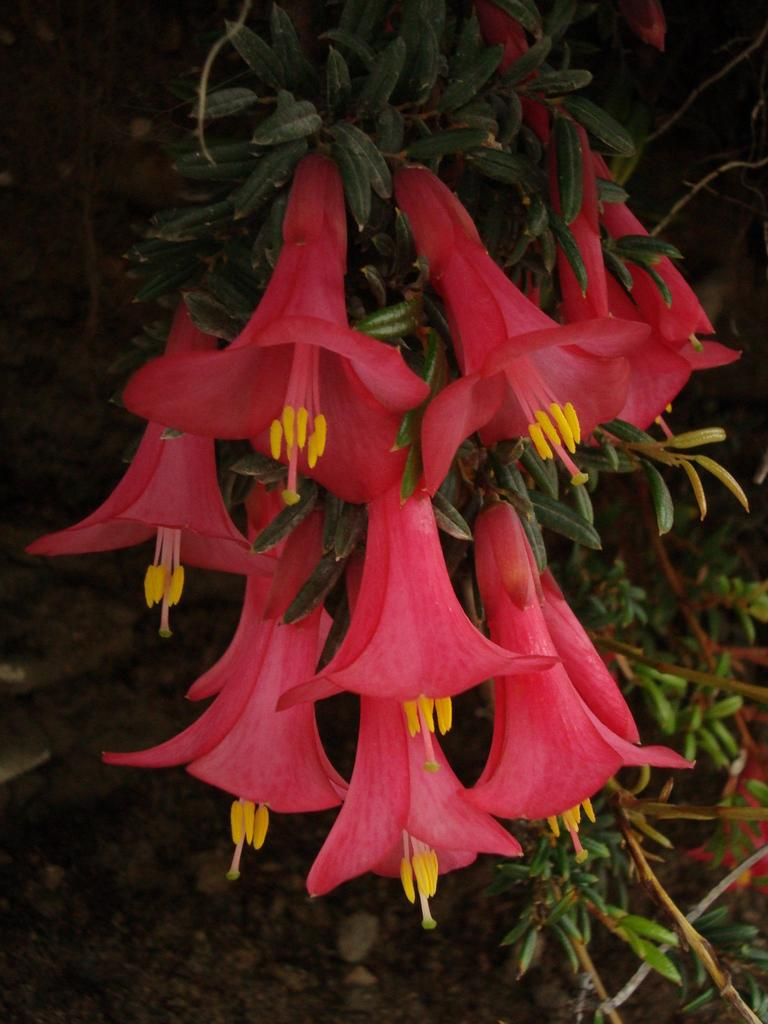What type of plant can be seen in the image? There is a plant with flowers in the image. Can you describe the background of the image? The background of the image is not clear. How many bats are visible in the image? There are no bats present in the image. What type of group is shown interacting with the plant in the image? There is no group present in the image; only the plant with flowers is visible. 